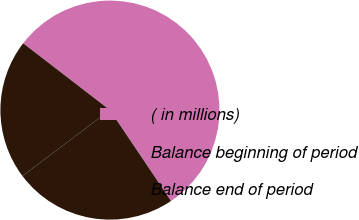Convert chart. <chart><loc_0><loc_0><loc_500><loc_500><pie_chart><fcel>( in millions)<fcel>Balance beginning of period<fcel>Balance end of period<nl><fcel>55.13%<fcel>24.15%<fcel>20.71%<nl></chart> 